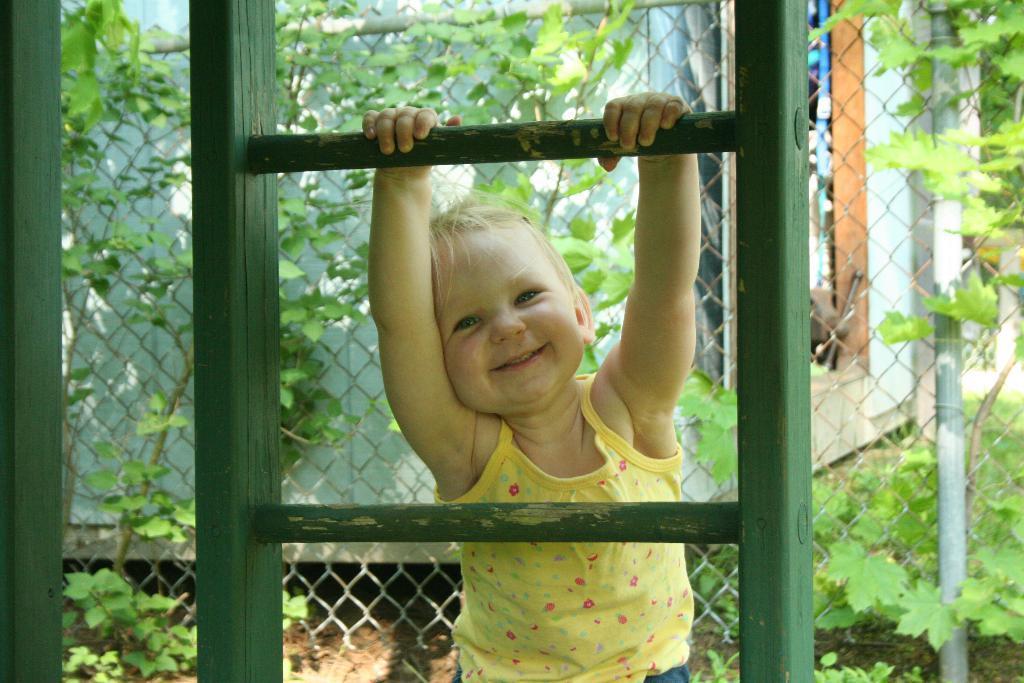Could you give a brief overview of what you see in this image? In the picture we can see a window and a child is holding a window road and smiling, behind the child we can see a fencing wall with some plants and a house wall. 